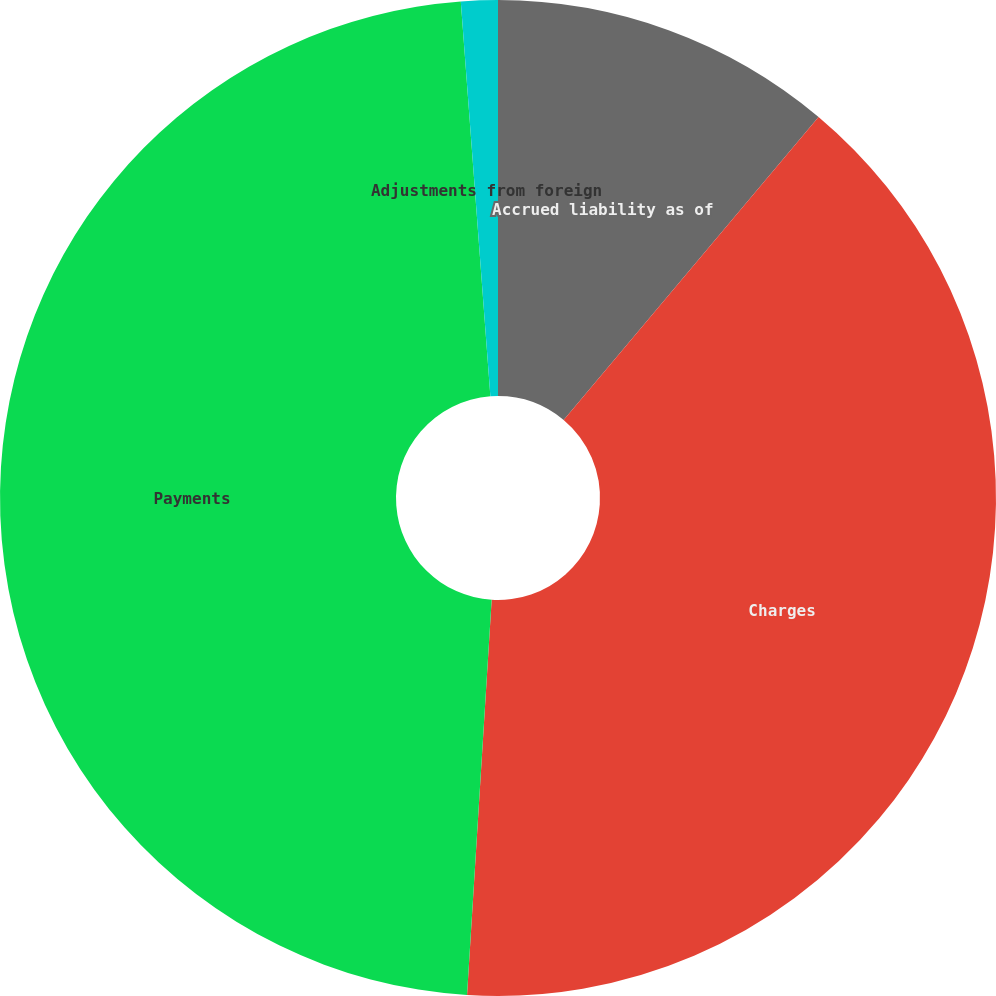<chart> <loc_0><loc_0><loc_500><loc_500><pie_chart><fcel>Accrued liability as of<fcel>Charges<fcel>Payments<fcel>Adjustments from foreign<nl><fcel>11.13%<fcel>39.86%<fcel>47.82%<fcel>1.19%<nl></chart> 